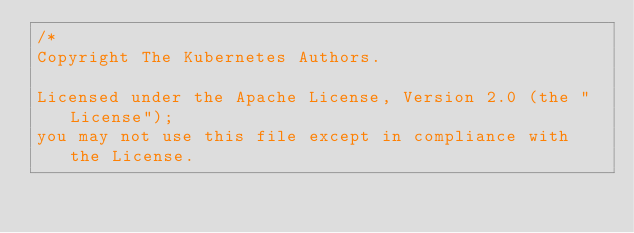Convert code to text. <code><loc_0><loc_0><loc_500><loc_500><_Go_>/*
Copyright The Kubernetes Authors.

Licensed under the Apache License, Version 2.0 (the "License");
you may not use this file except in compliance with the License.</code> 